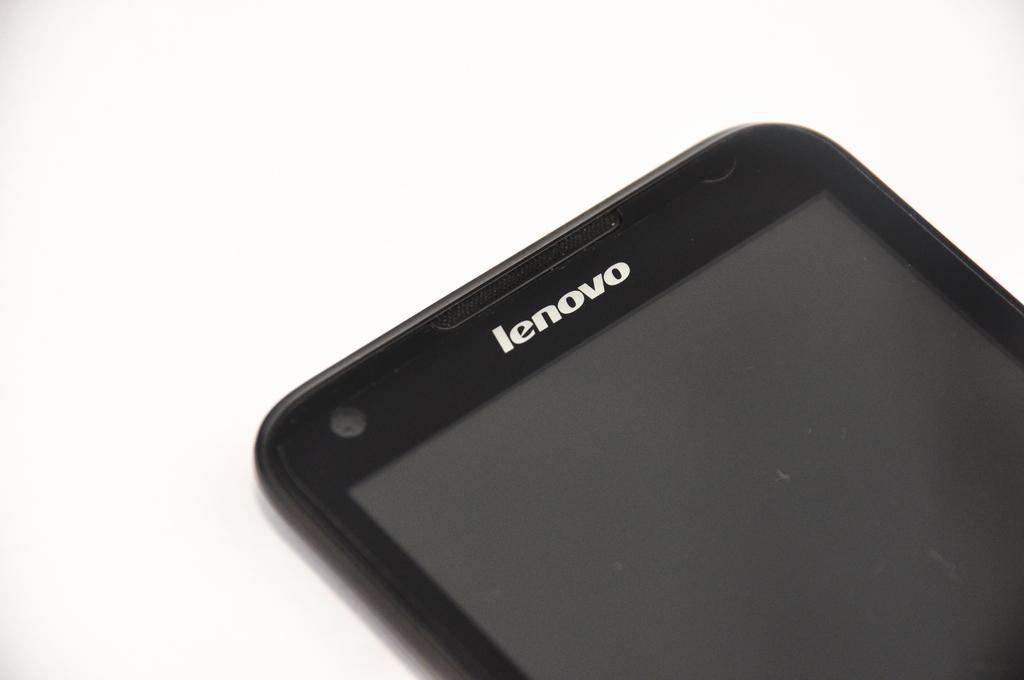What is the brand of phone?
Make the answer very short. Lenovo. 